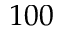<formula> <loc_0><loc_0><loc_500><loc_500>1 0 0</formula> 